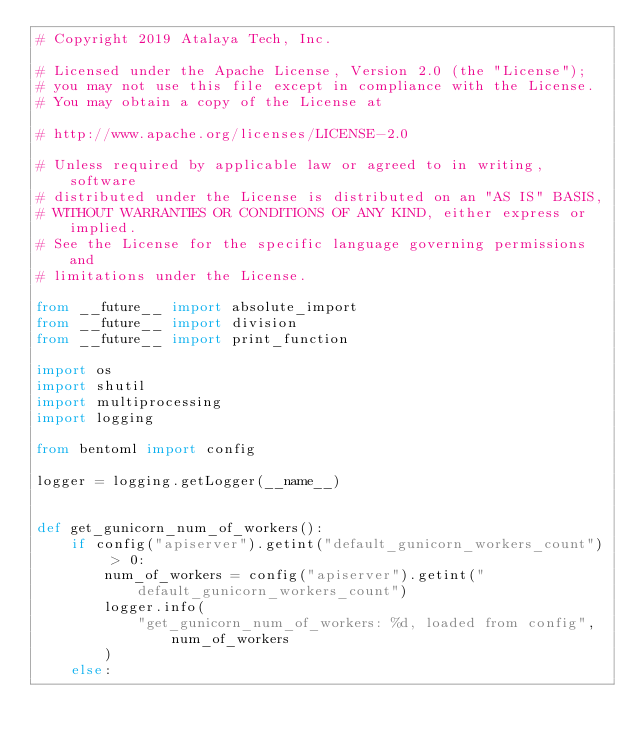<code> <loc_0><loc_0><loc_500><loc_500><_Python_># Copyright 2019 Atalaya Tech, Inc.

# Licensed under the Apache License, Version 2.0 (the "License");
# you may not use this file except in compliance with the License.
# You may obtain a copy of the License at

# http://www.apache.org/licenses/LICENSE-2.0

# Unless required by applicable law or agreed to in writing, software
# distributed under the License is distributed on an "AS IS" BASIS,
# WITHOUT WARRANTIES OR CONDITIONS OF ANY KIND, either express or implied.
# See the License for the specific language governing permissions and
# limitations under the License.

from __future__ import absolute_import
from __future__ import division
from __future__ import print_function

import os
import shutil
import multiprocessing
import logging

from bentoml import config

logger = logging.getLogger(__name__)


def get_gunicorn_num_of_workers():
    if config("apiserver").getint("default_gunicorn_workers_count") > 0:
        num_of_workers = config("apiserver").getint("default_gunicorn_workers_count")
        logger.info(
            "get_gunicorn_num_of_workers: %d, loaded from config", num_of_workers
        )
    else:</code> 